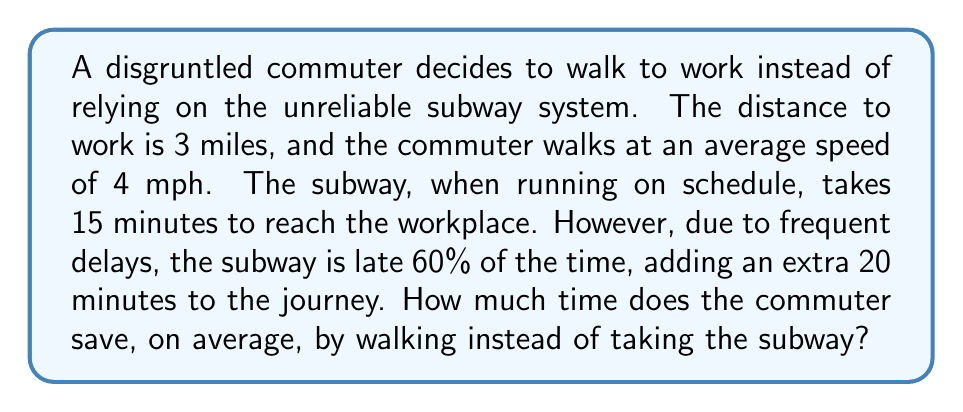Can you answer this question? Let's break this down step-by-step:

1. Calculate the time taken to walk to work:
   - Distance = 3 miles
   - Walking speed = 4 mph
   - Time = Distance / Speed
   $$\text{Walking time} = \frac{3 \text{ miles}}{4 \text{ mph}} = 0.75 \text{ hours} = 45 \text{ minutes}$$

2. Calculate the average time taken by the subway:
   - On-time trips (40% of the time): 15 minutes
   - Delayed trips (60% of the time): 15 + 20 = 35 minutes
   - Average subway time = (0.4 × 15) + (0.6 × 35)
   $$\text{Average subway time} = 0.4(15) + 0.6(35) = 6 + 21 = 27 \text{ minutes}$$

3. Calculate the time saved by walking:
   $$\text{Time saved} = \text{Average subway time} - \text{Walking time}$$
   $$\text{Time saved} = 27 \text{ minutes} - 45 \text{ minutes} = -18 \text{ minutes}$$

The negative result indicates that walking actually takes longer than the subway on average.
Answer: $-18$ minutes 